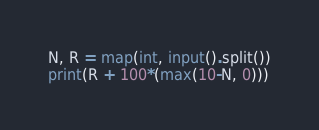<code> <loc_0><loc_0><loc_500><loc_500><_Python_>N, R = map(int, input().split())
print(R + 100*(max(10-N, 0)))</code> 